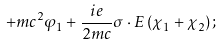<formula> <loc_0><loc_0><loc_500><loc_500>+ m c ^ { 2 } \varphi _ { 1 } + \frac { i e } { 2 m c } \sigma \cdot { E } \left ( \chi _ { 1 } + \chi _ { 2 } \right ) ;</formula> 